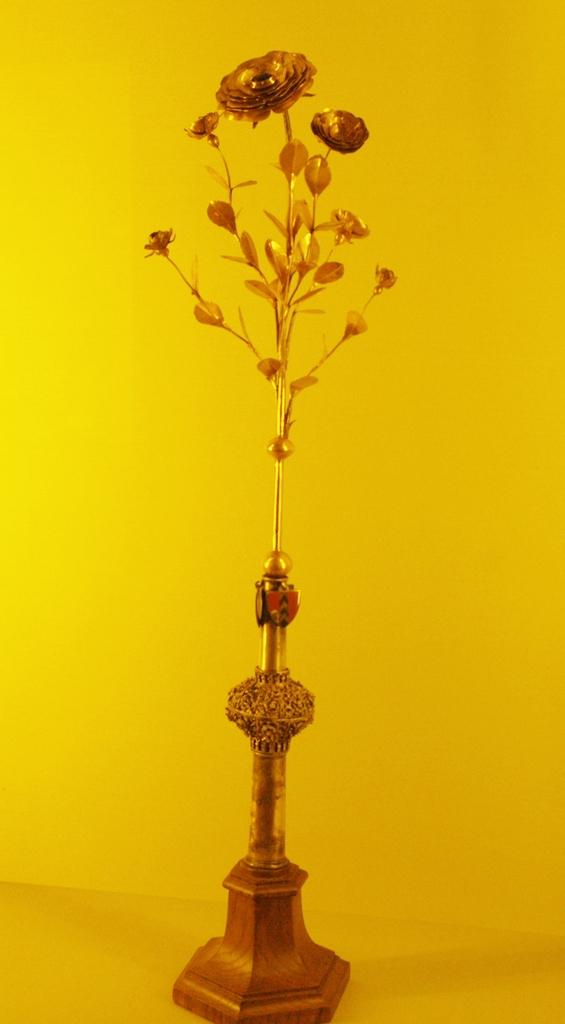What is the main object in the center of the image? There is a flower vase in the center of the image. What is the flower vase placed on? The flower vase is on a surface. What color is the background of the image? The background of the image is plain yellow color. What type of fear can be seen on the flower vase in the image? There is no fear present on the flower vase in the image, as it is an inanimate object. 